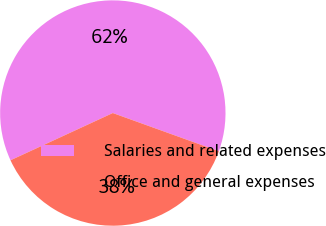Convert chart. <chart><loc_0><loc_0><loc_500><loc_500><pie_chart><fcel>Salaries and related expenses<fcel>Office and general expenses<nl><fcel>62.39%<fcel>37.61%<nl></chart> 